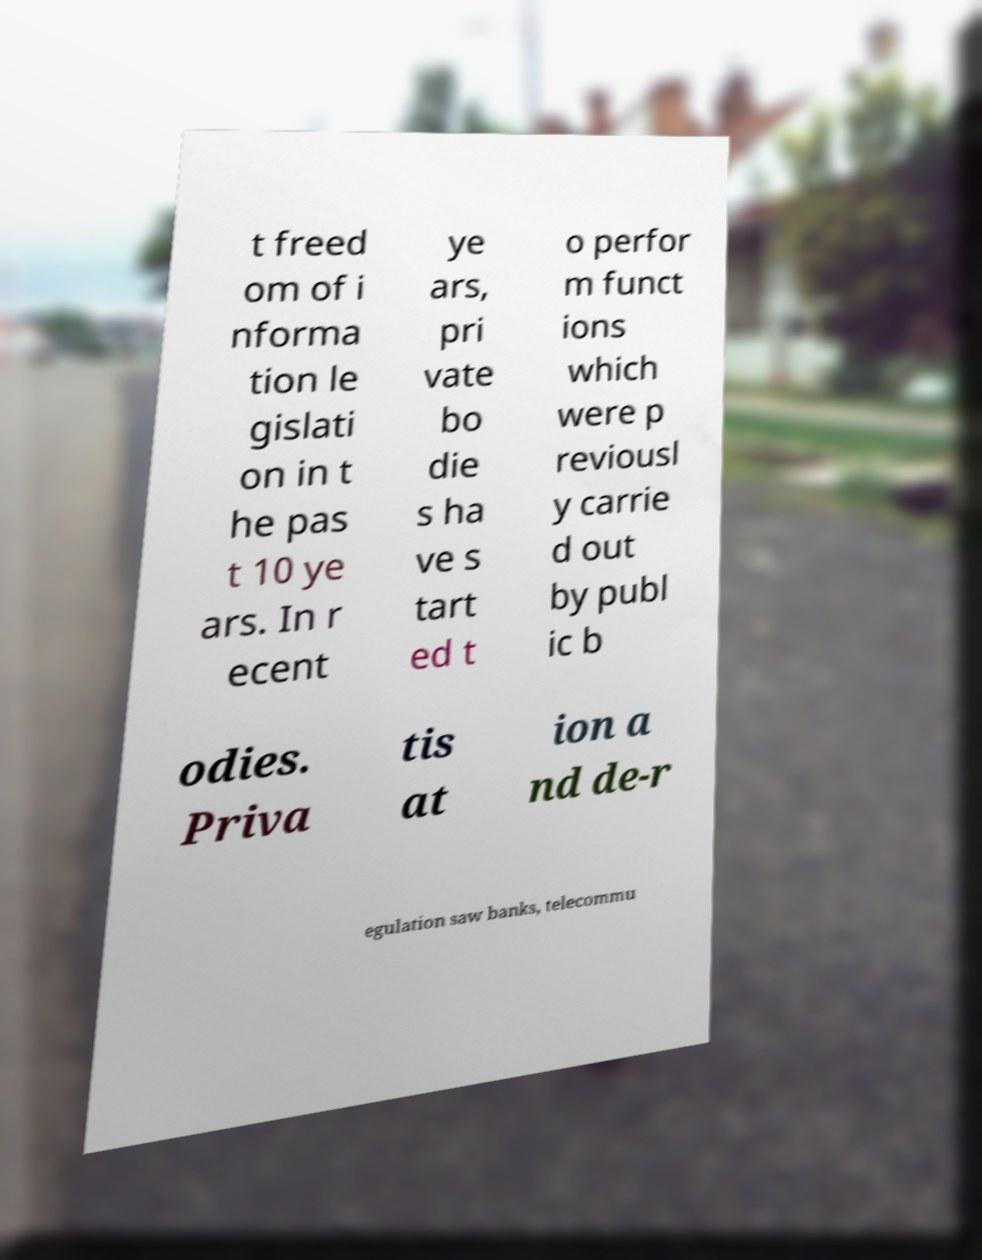What messages or text are displayed in this image? I need them in a readable, typed format. t freed om of i nforma tion le gislati on in t he pas t 10 ye ars. In r ecent ye ars, pri vate bo die s ha ve s tart ed t o perfor m funct ions which were p reviousl y carrie d out by publ ic b odies. Priva tis at ion a nd de-r egulation saw banks, telecommu 